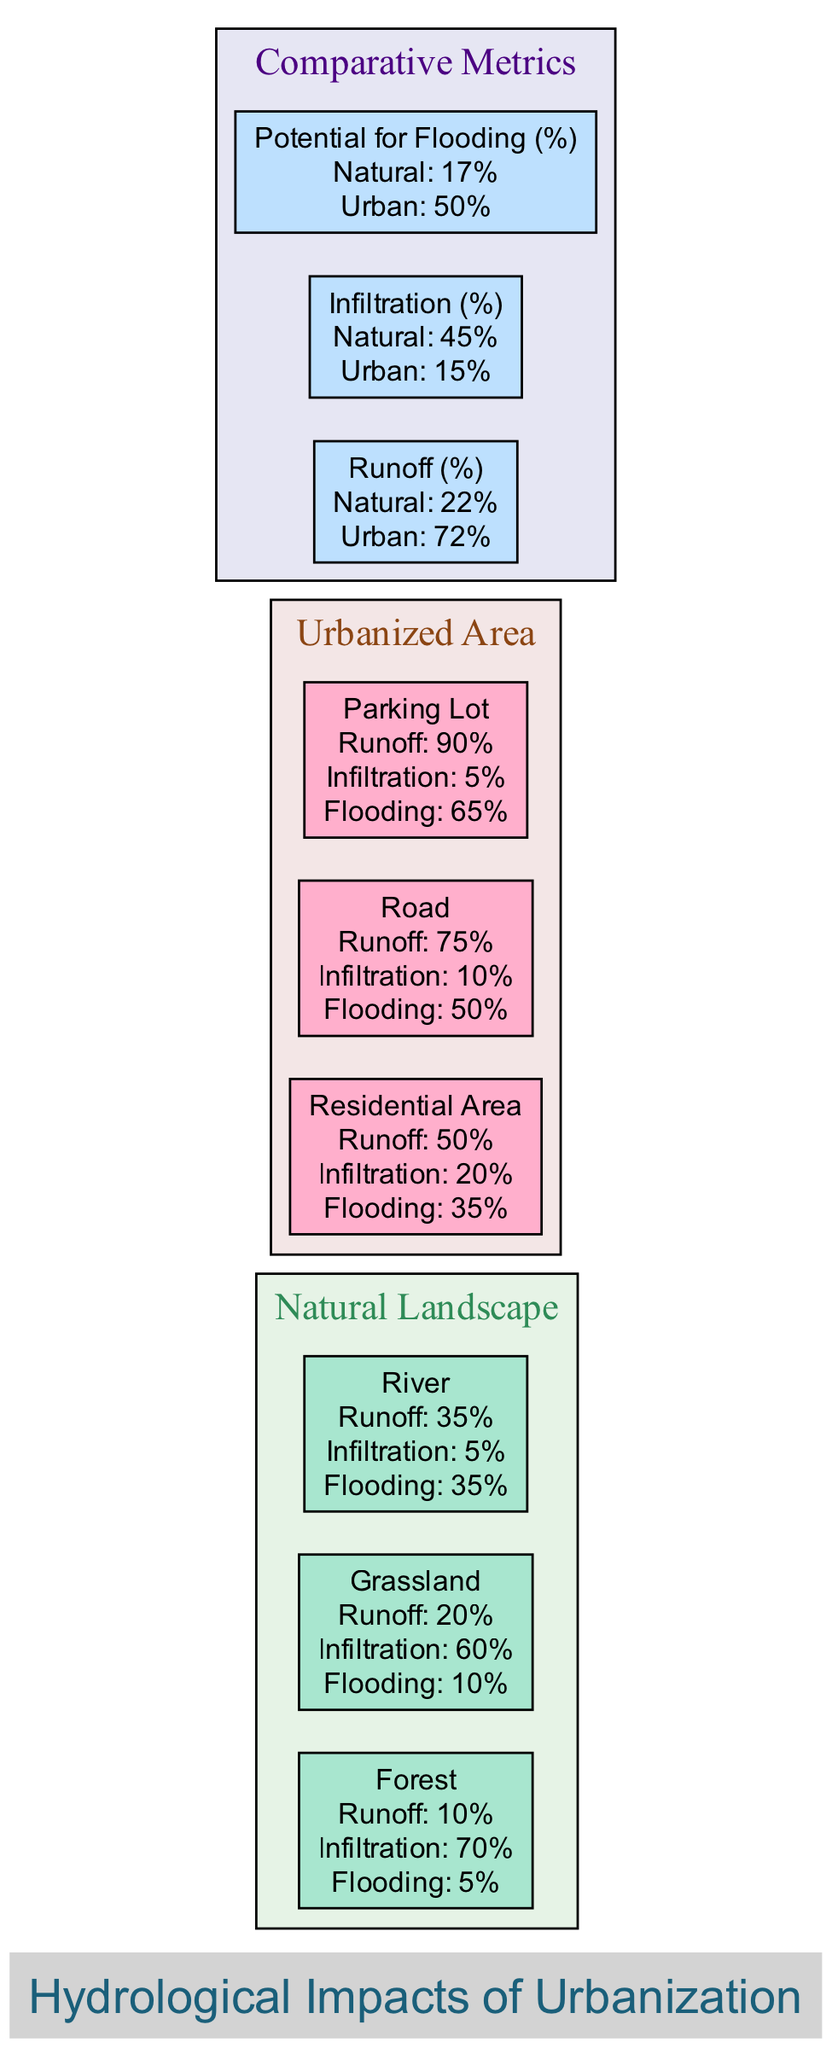What is the runoff percentage for the forest in the natural landscape? The diagram specifies that the forest has a runoff of 10%. This is directly stated in the node for the forest in the natural landscape section.
Answer: 10% What is the infiltration percentage for the residential area in the urbanized area? In the urbanized area section of the diagram, the residential area is shown to have an infiltration percentage of 20%. This value is found in the corresponding node for the residential area.
Answer: 20% Which area has the highest potential for flooding? The diagram indicates the parking lot in the urbanized area has the highest potential for flooding at 65%. This is the maximum value among all sections.
Answer: Parking Lot What is the total runoff percentage for the natural landscape? The runoff percentages for the natural landscape are 10% (forest), 20% (grassland), and 35% (river). Adding these gives a total runoff percentage of 22%.
Answer: 22% What is the comparative infiltration percentage between the natural landscape and urbanized area? The diagram shows that the natural landscape has an infiltration of 45% while the urbanized area has 15%. To determine the comparative values, we note the respective percentages given in the comparative metrics section.
Answer: 45% Natural, 15% Urban What is the increase in potential for flooding when comparing natural and urbanized areas? The potential for flooding in the natural landscape is 17% while in the urbanized area it is 50%. The increase is calculated as 50% (urban) - 17% (natural) = 33%.
Answer: 33% Which element in the urbanized area has the lowest infiltration rate? The parking lot is identified in the urbanized area with the lowest infiltration rate of 5%. This is specifically mentioned in the corresponding node for the parking lot.
Answer: Parking Lot What is the runoff percentage for the road in the urbanized area? According to the urbanized area section of the diagram, the road has a runoff percentage of 75%. This is mentioned in the node related to the road.
Answer: 75% What is the total flooding potential in the urbanized area when combining elements? The flooding potentials are 35% (residential area), 50% (road), and 65% (parking lot). However, since we are looking for potential without overlap, the highest value is primarily noted at 65% for the parking lot.
Answer: 65% 